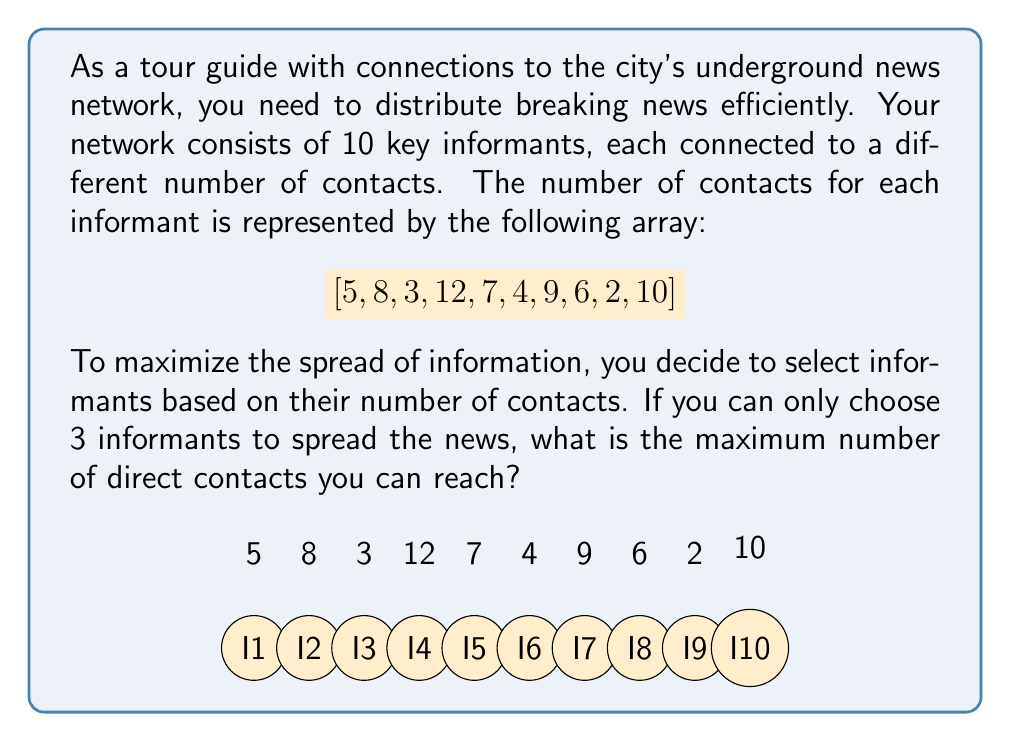Provide a solution to this math problem. To solve this problem, we need to find the three largest numbers in the given array, as these represent the informants who can reach the most contacts. Here's the step-by-step process:

1) First, let's order the array from largest to smallest:
   $[12, 10, 9, 8, 7, 6, 5, 4, 3, 2]$

2) We need to select the top 3 numbers, which are:
   $12, 10,$ and $9$

3) To find the total number of contacts reached, we sum these three numbers:

   $$12 + 10 + 9 = 31$$

Therefore, by selecting the three informants with the most contacts, we can reach a maximum of 31 direct contacts.

This approach ensures the most efficient distribution pattern for spreading information through the interconnected nodes (informants) in our network.
Answer: 31 contacts 